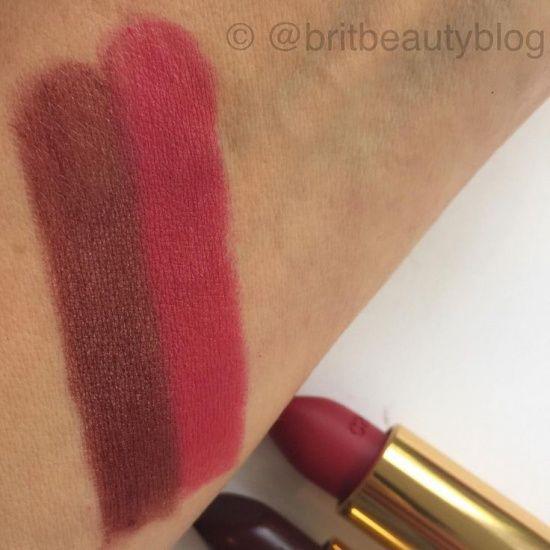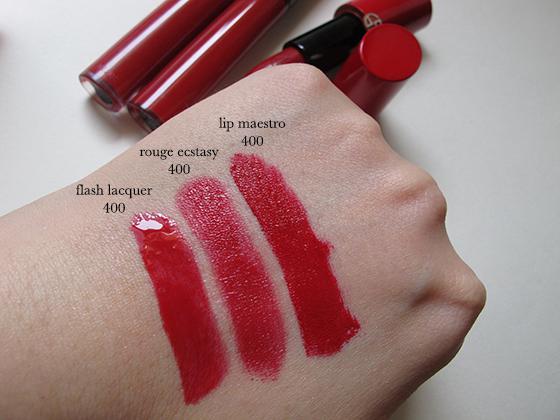The first image is the image on the left, the second image is the image on the right. Analyze the images presented: Is the assertion "Each image shows an arm comparing the shades of at least two lipstick colors." valid? Answer yes or no. Yes. The first image is the image on the left, the second image is the image on the right. Evaluate the accuracy of this statement regarding the images: "The left image shows skin with two lipstick stripes on it, and the right image shows the top of a hand with three lipstick stripes.". Is it true? Answer yes or no. Yes. 